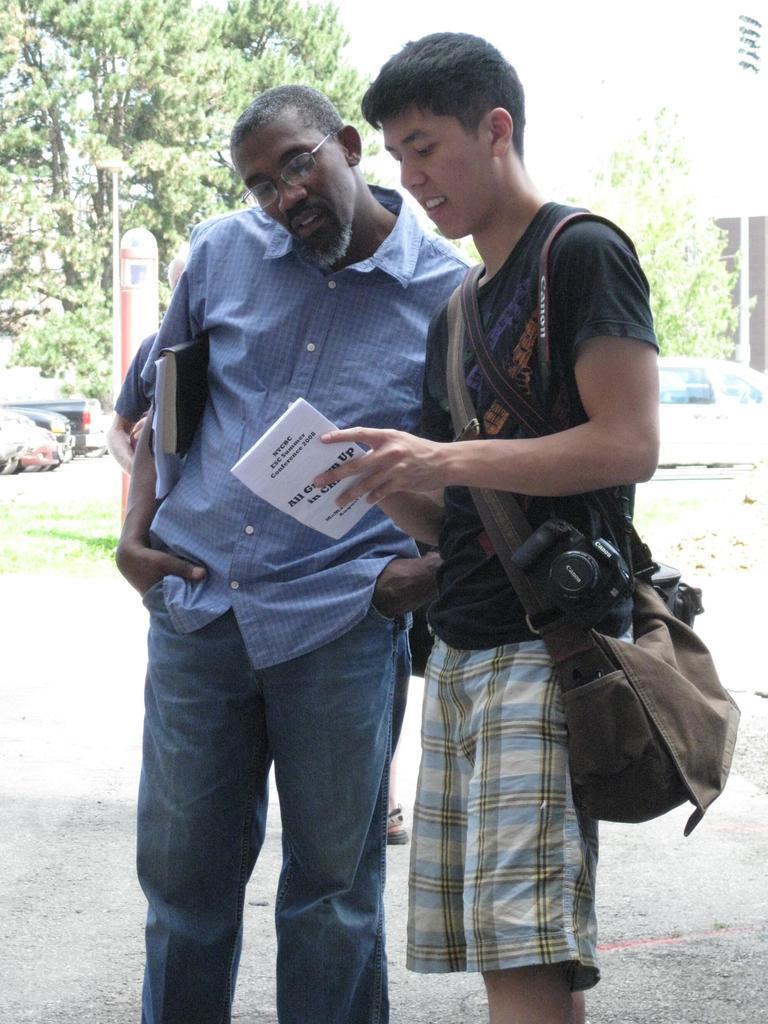Describe this image in one or two sentences. In this image we can see men standing on the ground and holding books, camera and a bag. In the background we can see buildings, trees, motor vehicles and grass. 